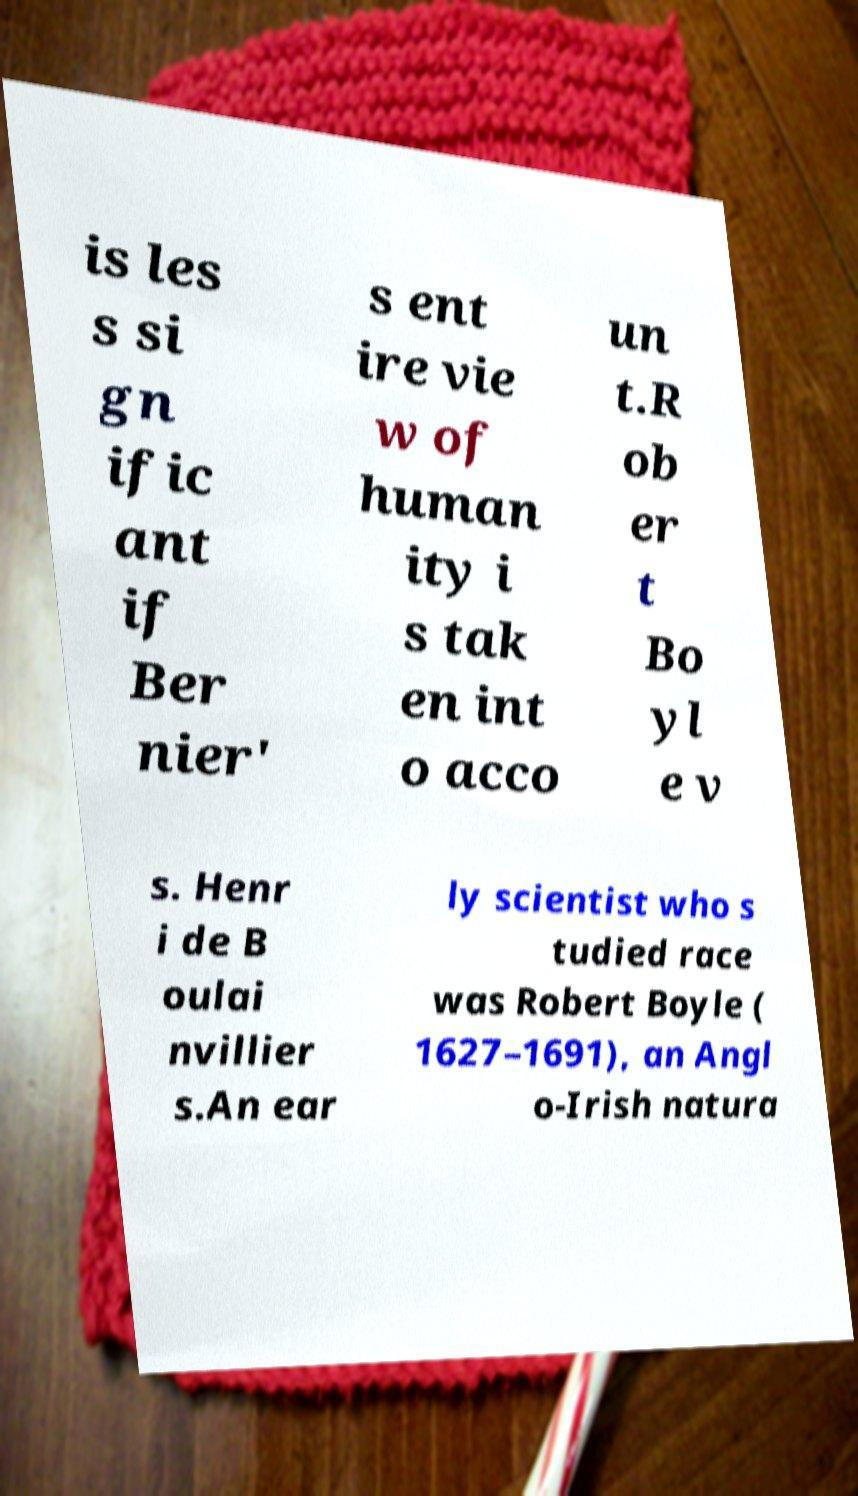There's text embedded in this image that I need extracted. Can you transcribe it verbatim? is les s si gn ific ant if Ber nier' s ent ire vie w of human ity i s tak en int o acco un t.R ob er t Bo yl e v s. Henr i de B oulai nvillier s.An ear ly scientist who s tudied race was Robert Boyle ( 1627–1691), an Angl o-Irish natura 